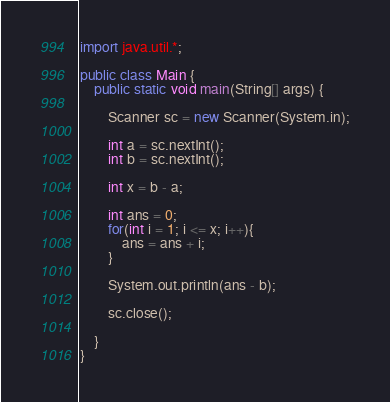<code> <loc_0><loc_0><loc_500><loc_500><_Java_>import java.util.*;

public class Main {
    public static void main(String[] args) {
        
        Scanner sc = new Scanner(System.in);
        
        int a = sc.nextInt();
        int b = sc.nextInt();
        
        int x = b - a;
        
        int ans = 0;
        for(int i = 1; i <= x; i++){
            ans = ans + i;
        }
        
        System.out.println(ans - b);
        
        sc.close();
        
    }
}
</code> 